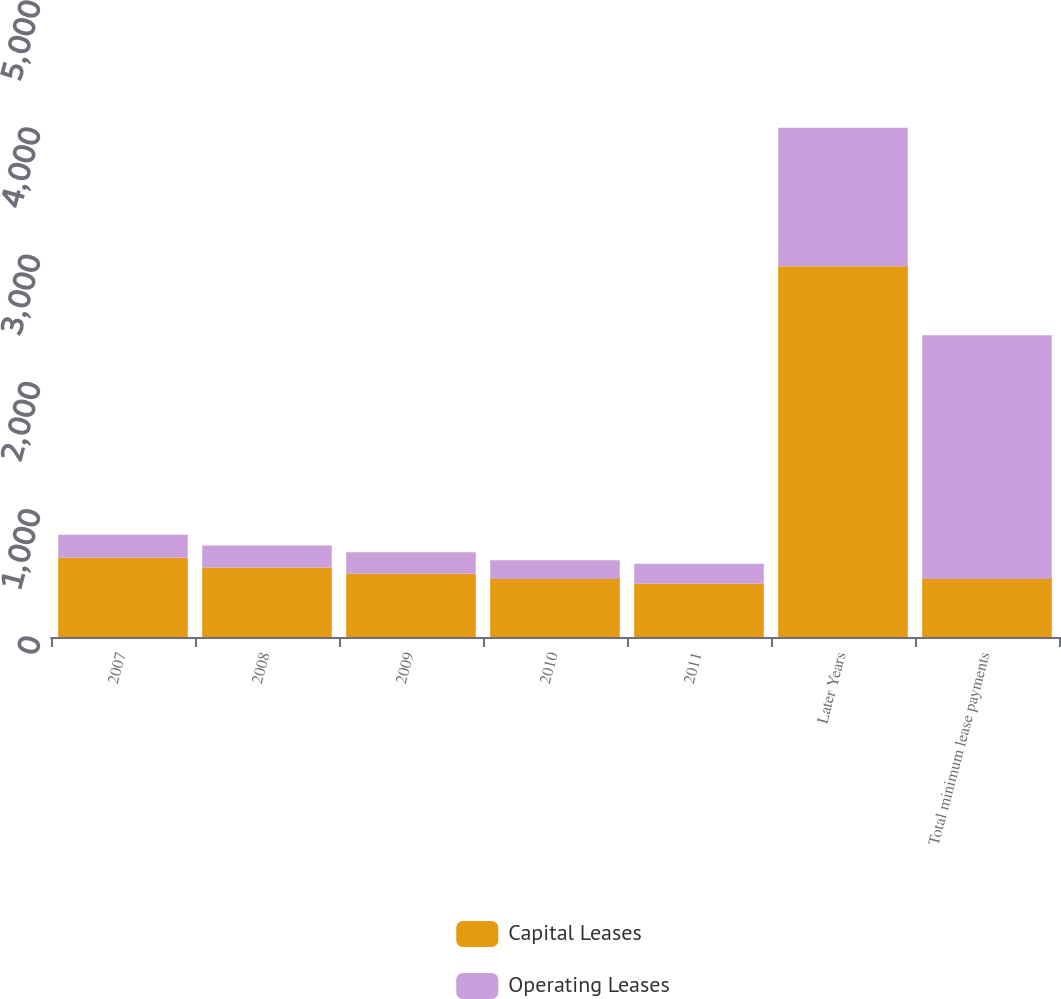<chart> <loc_0><loc_0><loc_500><loc_500><stacked_bar_chart><ecel><fcel>2007<fcel>2008<fcel>2009<fcel>2010<fcel>2011<fcel>Later Years<fcel>Total minimum lease payments<nl><fcel>Capital Leases<fcel>624<fcel>546<fcel>498<fcel>456<fcel>419<fcel>2914<fcel>456<nl><fcel>Operating Leases<fcel>180<fcel>173<fcel>168<fcel>148<fcel>157<fcel>1090<fcel>1916<nl></chart> 